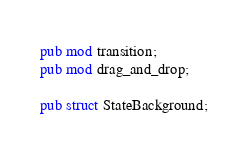Convert code to text. <code><loc_0><loc_0><loc_500><loc_500><_Rust_>pub mod transition;
pub mod drag_and_drop;

pub struct StateBackground;</code> 